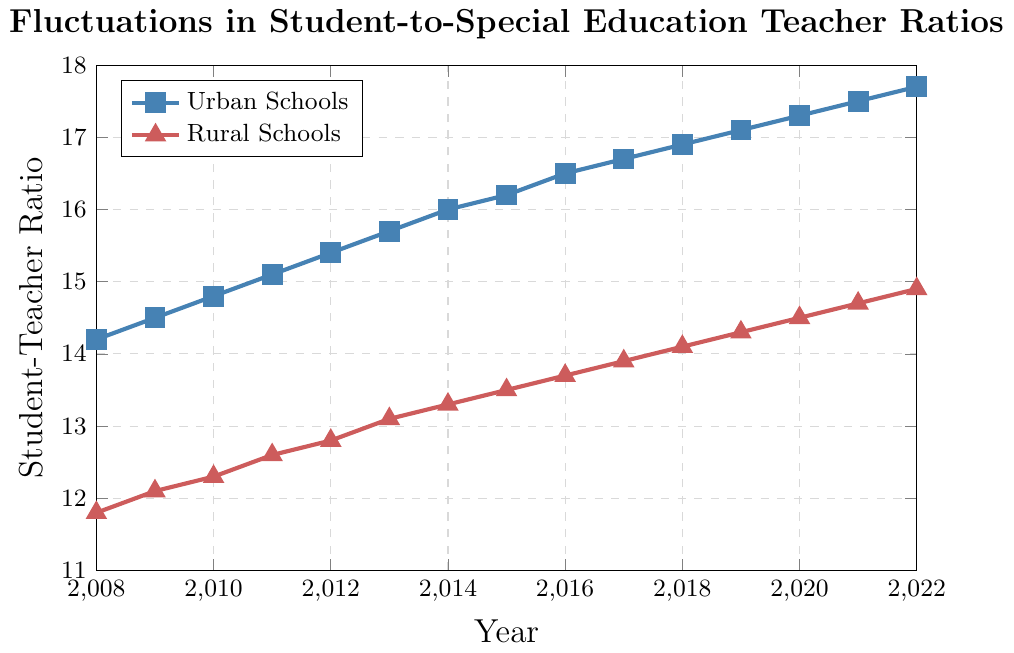What is the student-to-teacher ratio for urban and rural schools in 2015? To find the student-to-teacher ratios for urban and rural schools in 2015, locate the year 2015 on the x-axis and read the corresponding values from the respective lines. For urban schools, the value is 16.2, and for rural schools, the value is 13.5.
Answer: Urban: 16.2, Rural: 13.5 How has the student-to-teacher ratio for urban schools changed from 2008 to 2022? Calculate the difference between the ratios in 2022 and 2008 by subtracting the 2008 value from the 2022 value for urban schools. The value in 2022 is 17.7 and in 2008 it is 14.2, so the change is 17.7 - 14.2 = 3.5.
Answer: Increased by 3.5 In which year did rural schools experience the highest student-to-teacher ratio, and what was the ratio? To find the peak ratio for rural schools, examine the line representing rural schools and locate the highest point. The highest point occurs in 2022 with a ratio of 14.9.
Answer: 2022, 14.9 Which had a higher student-to-teacher ratio in 2010, urban schools or rural schools, and by how much? Compare the ratios for urban and rural schools in 2010. The urban ratio is 14.8 and the rural ratio is 12.3. Calculate the difference: 14.8 - 12.3 = 2.5. Urban schools had a higher ratio by 2.5.
Answer: Urban, by 2.5 By how much did the student-to-teacher ratio for rural schools increase from 2008 to 2018? Calculate the difference between the ratios in 2018 and 2008 by subtracting the 2008 value from the 2018 value for rural schools. The value in 2018 is 14.1 and in 2008 it is 11.8, so the increase is 14.1 - 11.8 = 2.3.
Answer: Increased by 2.3 What is the average student-to-teacher ratio for urban schools from 2008 to 2022? To find the average ratio over the years for urban schools, add all the yearly ratios and divide by the number of years. Sum of ratios = 14.2 + 14.5 + 14.8 + 15.1 + 15.4 + 15.7 + 16.0 + 16.2 + 16.5 + 16.7 + 16.9 + 17.1 + 17.3 + 17.5 + 17.7 = 243.6. Average = 243.6 / 15 = 16.24.
Answer: 16.24 Are the student-to-teacher ratios for urban and rural schools converging or diverging over the given period? To determine if the ratios are converging or diverging, analyze the trends of both lines. Both ratios are increasing, but the urban ratio increases more rapidly than the rural one, indicating that they are diverging over time.
Answer: Diverging What is the difference in student-to-teacher ratio between urban and rural schools in the last recorded year? Compare the ratios for urban and rural schools in 2022. The urban ratio is 17.7 and the rural ratio is 14.9. Calculate the difference: 17.7 - 14.9 = 2.8.
Answer: 2.8 At what rate did the student-to-teacher ratio for urban schools grow from 2010 to 2020? Calculate the difference between the ratios in 2020 and 2010, and then divide by the number of years to find the annual growth rate. The ratio in 2020 is 17.3 and in 2010 it is 14.8. Difference = 17.3 - 14.8 = 2.5. Annual growth rate = 2.5 / 10 = 0.25.
Answer: 0.25 per year 